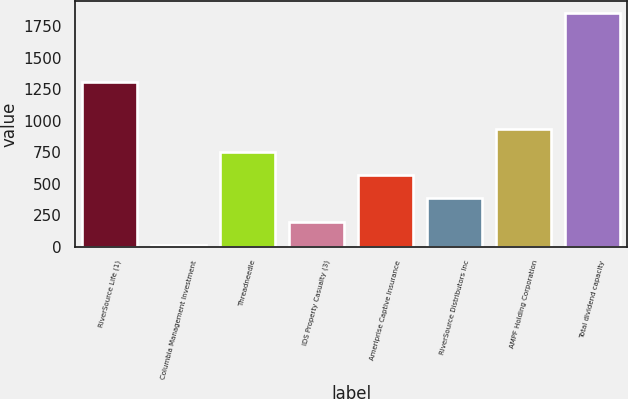Convert chart to OTSL. <chart><loc_0><loc_0><loc_500><loc_500><bar_chart><fcel>RiverSource Life (1)<fcel>Columbia Management Investment<fcel>Threadneedle<fcel>IDS Property Casualty (3)<fcel>Ameriprise Captive Insurance<fcel>RiverSource Distributors Inc<fcel>AMPF Holding Corporation<fcel>Total dividend capacity<nl><fcel>1305.5<fcel>14<fcel>752<fcel>198.5<fcel>567.5<fcel>383<fcel>936.5<fcel>1859<nl></chart> 